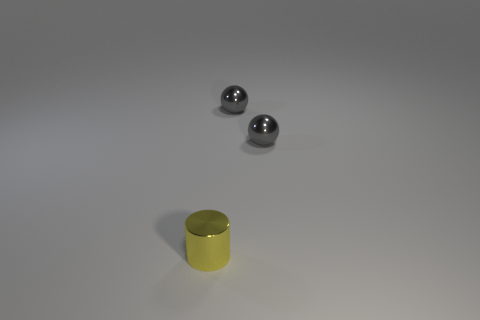Are there any spheres of the same color as the cylinder?
Give a very brief answer. No. How many gray spheres are made of the same material as the tiny yellow cylinder?
Offer a terse response. 2. What number of spheres are either tiny shiny objects or large red rubber things?
Offer a very short reply. 2. Are there any other things that are the same shape as the yellow metallic object?
Offer a very short reply. No. How many things are either small gray balls or tiny metal things that are behind the small yellow metallic object?
Ensure brevity in your answer.  2. Is the number of yellow metal objects that are on the left side of the tiny yellow thing less than the number of spheres?
Offer a very short reply. Yes. How many small yellow metallic objects are there?
Offer a terse response. 1. Is there anything else that is the same size as the yellow cylinder?
Ensure brevity in your answer.  Yes. Are there fewer purple cubes than small metal things?
Your response must be concise. Yes. What number of rubber objects are either yellow cylinders or small objects?
Provide a short and direct response. 0. 